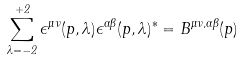Convert formula to latex. <formula><loc_0><loc_0><loc_500><loc_500>\sum _ { \lambda = - 2 } ^ { + 2 } \epsilon ^ { \mu \nu } ( p , \lambda ) \epsilon ^ { \alpha \beta } ( p , \lambda ) ^ { * } = B ^ { \mu \nu , \alpha \beta } ( p )</formula> 